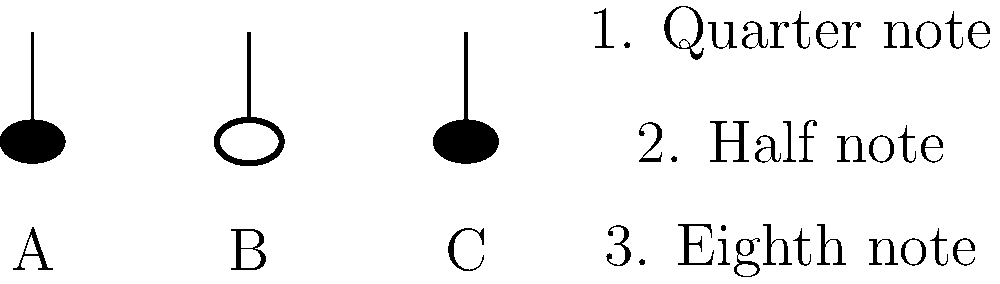As a music app developer, you're implementing a feature to display musical notation. Match the graphical representations of notes (A, B, C) with their corresponding durations (1, 2, 3). Which combination correctly pairs each note with its duration? Let's analyze each note representation and its corresponding duration:

1. Note A: This note has a filled (black) oval head with a stem. This represents an eighth note or a quarter note, depending on the presence of a flag or beam (not shown here).

2. Note B: This note has an open (white) oval head with a stem. This represents a half note.

3. Note C: This note has a filled (black) oval head with a stem, similar to Note A. Without additional context (like flags or beams), we'll assume it represents the same duration as Note A.

4. Duration 1 (Quarter note): A quarter note is represented by a filled oval head with a stem.

5. Duration 2 (Half note): A half note is represented by an open oval head with a stem, matching Note B.

6. Duration 3 (Eighth note): An eighth note is represented by a filled oval head with a stem and a flag (not shown here).

Given the information provided, we can deduce:
- Note B matches Duration 2 (Half note)
- Notes A and C could represent either Duration 1 (Quarter note) or Duration 3 (Eighth note)

However, since we need to match all three notes, and there's no visual distinction between A and C, we must assume they represent different durations. The most logical pairing would be:

A - 3 (Eighth note)
B - 2 (Half note)
C - 1 (Quarter note)

This combination ensures each note is matched with a unique duration while maintaining consistency with standard musical notation.
Answer: A3, B2, C1 